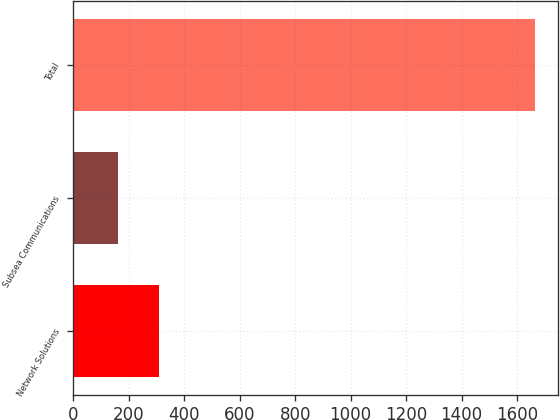Convert chart to OTSL. <chart><loc_0><loc_0><loc_500><loc_500><bar_chart><fcel>Network Solutions<fcel>Subsea Communications<fcel>Total<nl><fcel>310.3<fcel>160<fcel>1663<nl></chart> 